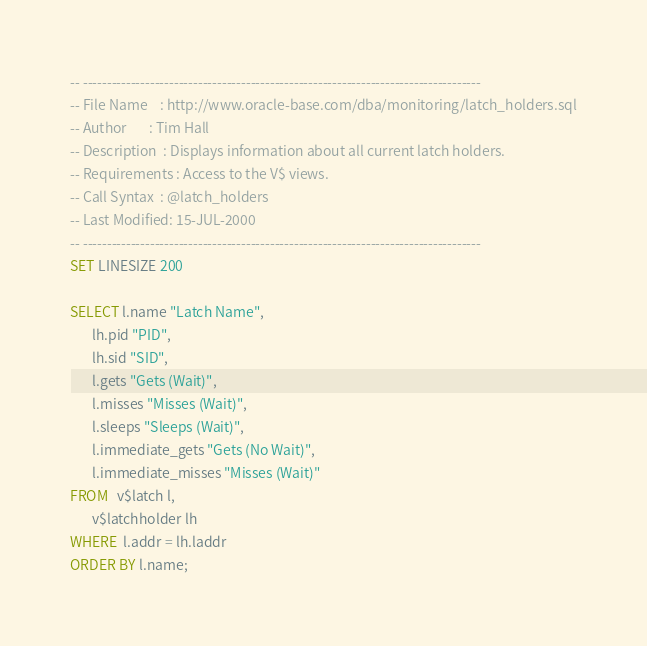Convert code to text. <code><loc_0><loc_0><loc_500><loc_500><_SQL_>-- -----------------------------------------------------------------------------------
-- File Name    : http://www.oracle-base.com/dba/monitoring/latch_holders.sql
-- Author       : Tim Hall
-- Description  : Displays information about all current latch holders.
-- Requirements : Access to the V$ views.
-- Call Syntax  : @latch_holders
-- Last Modified: 15-JUL-2000
-- -----------------------------------------------------------------------------------
SET LINESIZE 200

SELECT l.name "Latch Name",
       lh.pid "PID",
       lh.sid "SID",
       l.gets "Gets (Wait)",
       l.misses "Misses (Wait)",
       l.sleeps "Sleeps (Wait)",
       l.immediate_gets "Gets (No Wait)",
       l.immediate_misses "Misses (Wait)"
FROM   v$latch l,
       v$latchholder lh
WHERE  l.addr = lh.laddr
ORDER BY l.name;
</code> 